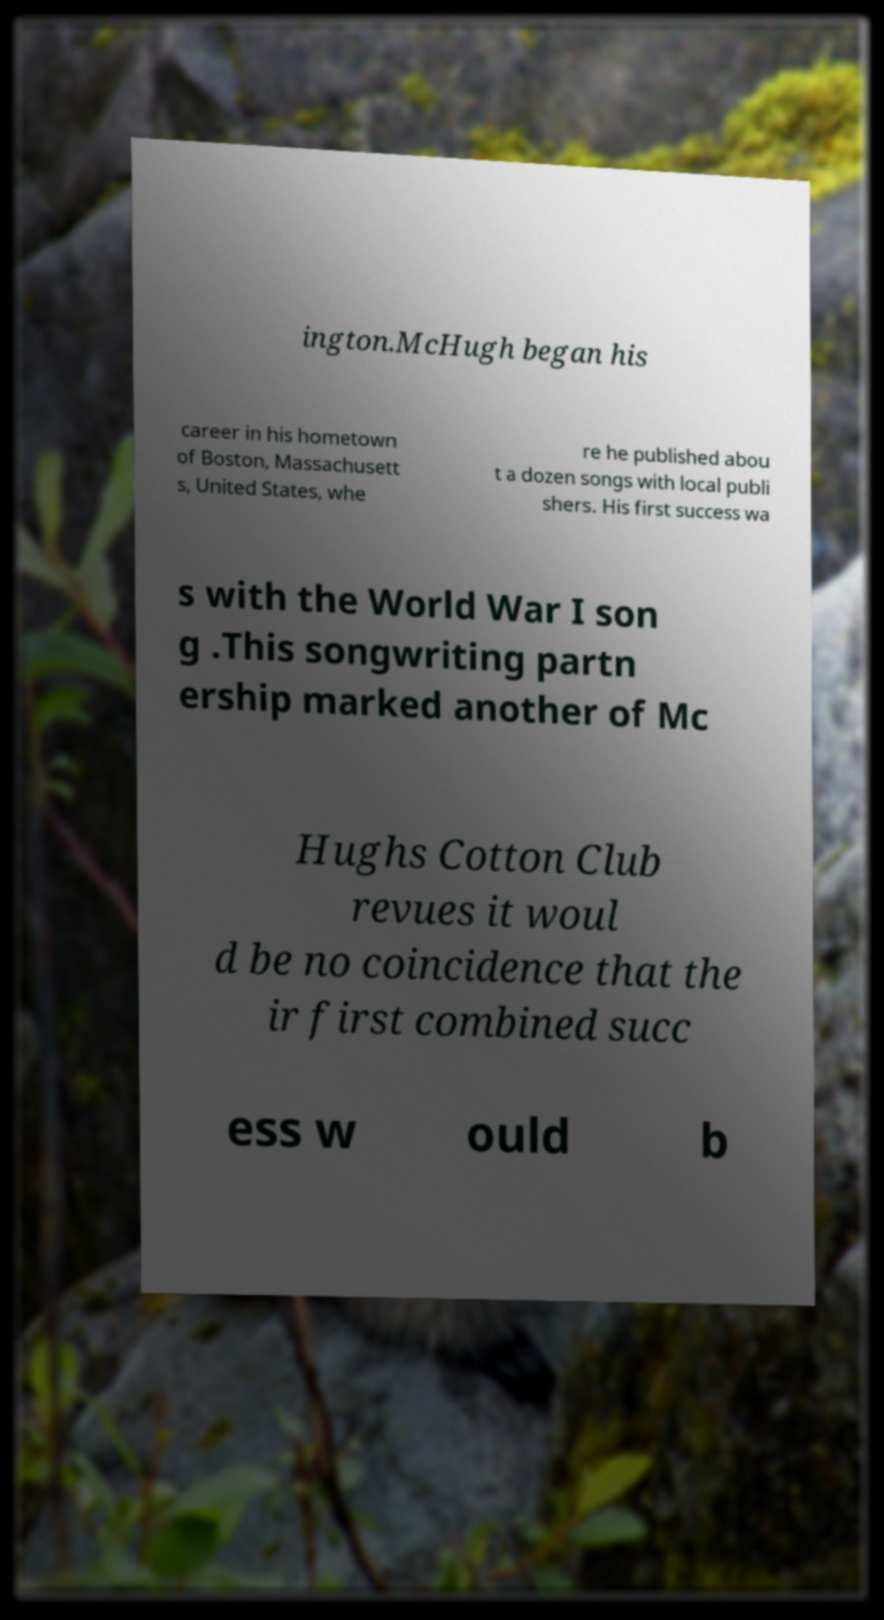For documentation purposes, I need the text within this image transcribed. Could you provide that? ington.McHugh began his career in his hometown of Boston, Massachusett s, United States, whe re he published abou t a dozen songs with local publi shers. His first success wa s with the World War I son g .This songwriting partn ership marked another of Mc Hughs Cotton Club revues it woul d be no coincidence that the ir first combined succ ess w ould b 